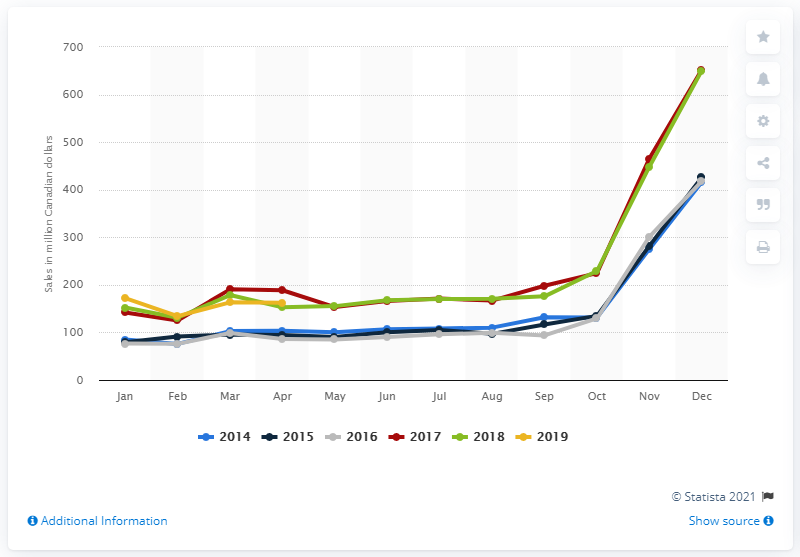Mention a couple of crucial points in this snapshot. The retail sales of toys, games, and hobby supplies in Canada in April 2019 were approximately CAD 162.35. 